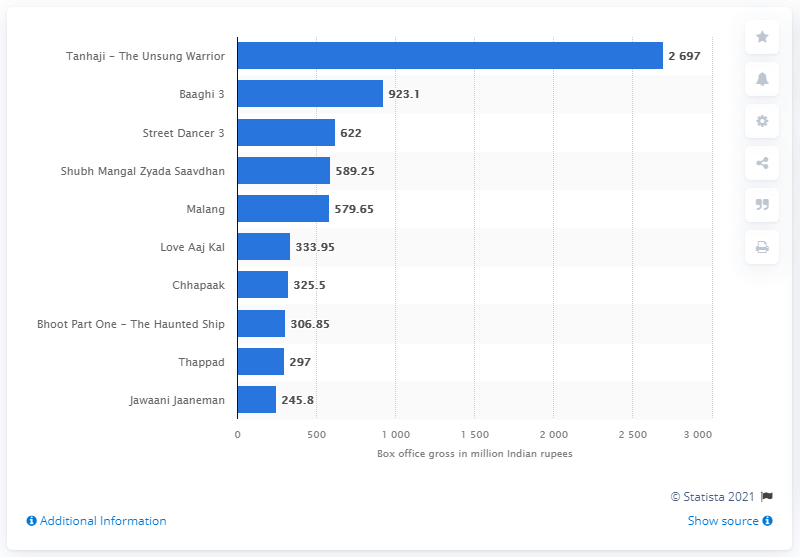Draw attention to some important aspects in this diagram. The collection of Baaghi 3 was 923.1 crores. In 2020, the highest grossing Bollywood movie produced in India was 'Street Dancer 3', which generated substantial revenue at the box office. Tanhaji - The Unsung Warrior" has collected 2697 Indian rupees. 